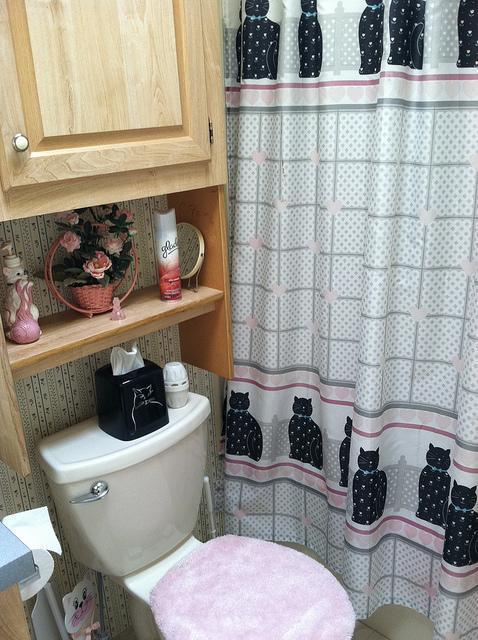How many cats are in the photo?
Give a very brief answer. 3. 